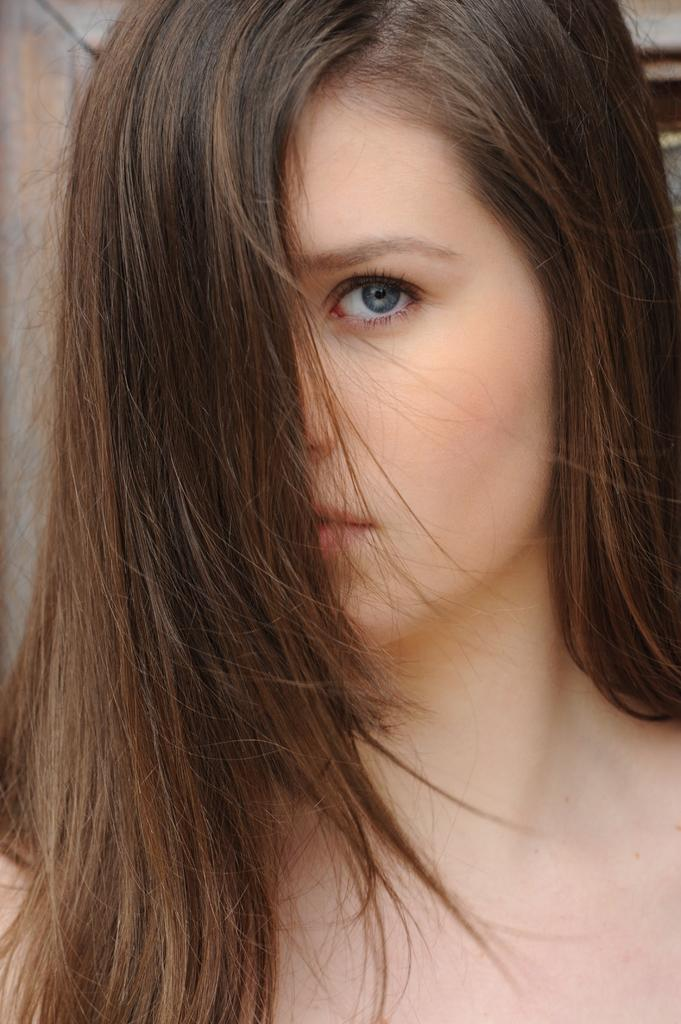Who is the main subject in the image? There is a girl in the image. Can you describe the wooden object in the background? There is a wooden object in the background of the image. What type of juice is the girl drinking in the image? There is no juice present in the image; the girl is the only subject mentioned. 